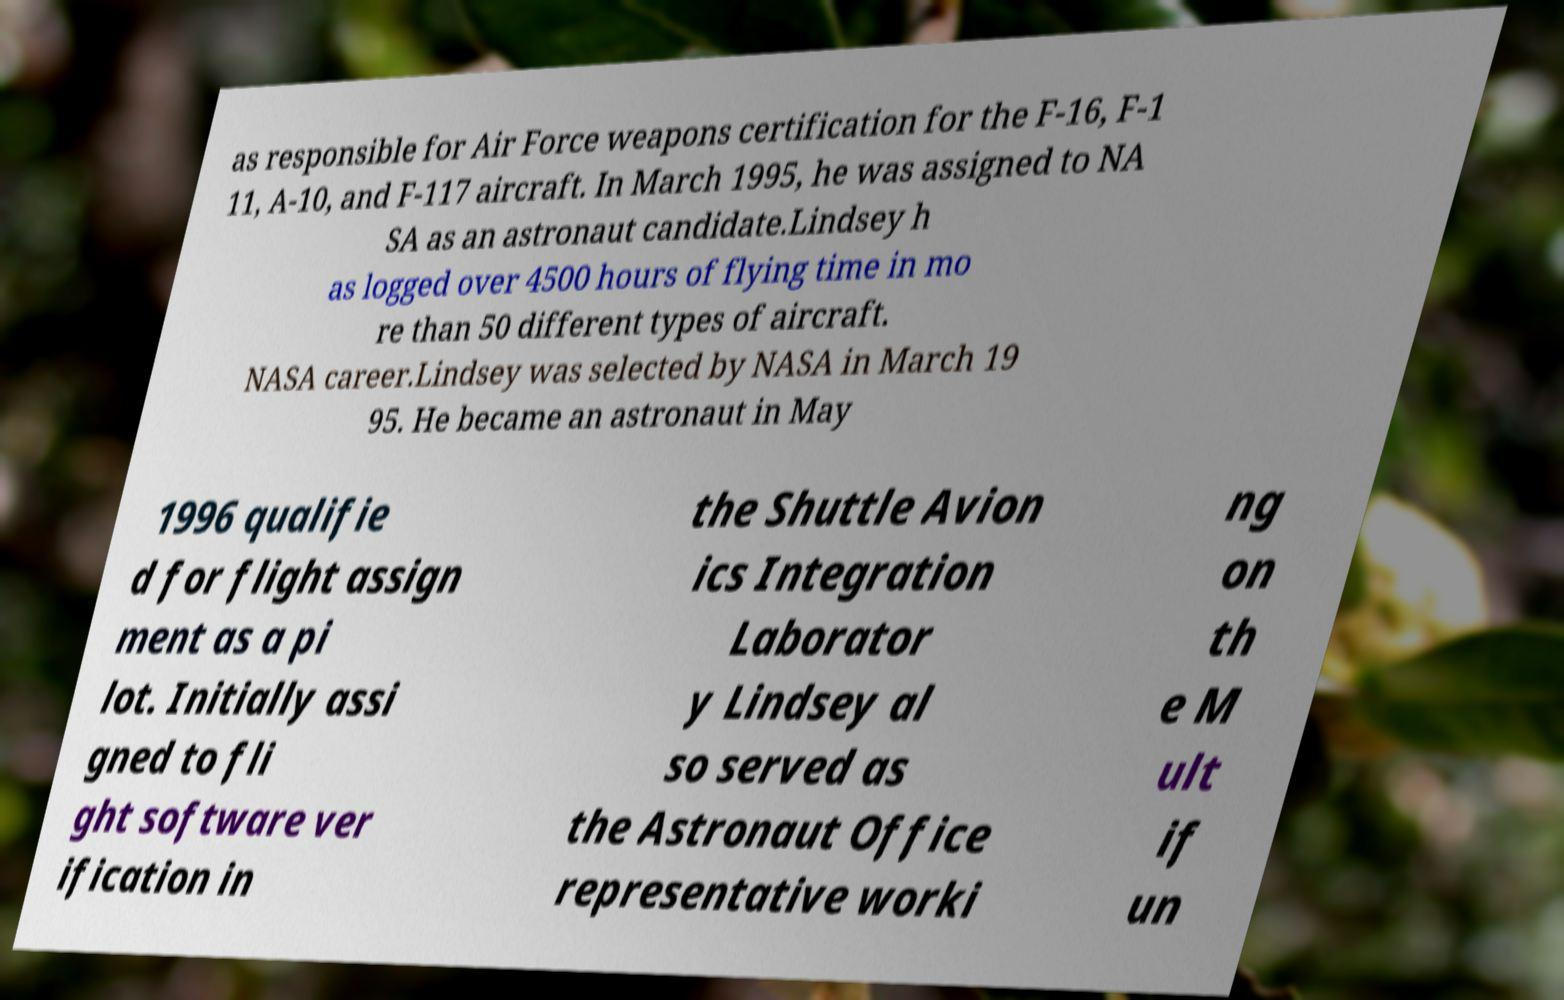There's text embedded in this image that I need extracted. Can you transcribe it verbatim? as responsible for Air Force weapons certification for the F-16, F-1 11, A-10, and F-117 aircraft. In March 1995, he was assigned to NA SA as an astronaut candidate.Lindsey h as logged over 4500 hours of flying time in mo re than 50 different types of aircraft. NASA career.Lindsey was selected by NASA in March 19 95. He became an astronaut in May 1996 qualifie d for flight assign ment as a pi lot. Initially assi gned to fli ght software ver ification in the Shuttle Avion ics Integration Laborator y Lindsey al so served as the Astronaut Office representative worki ng on th e M ult if un 